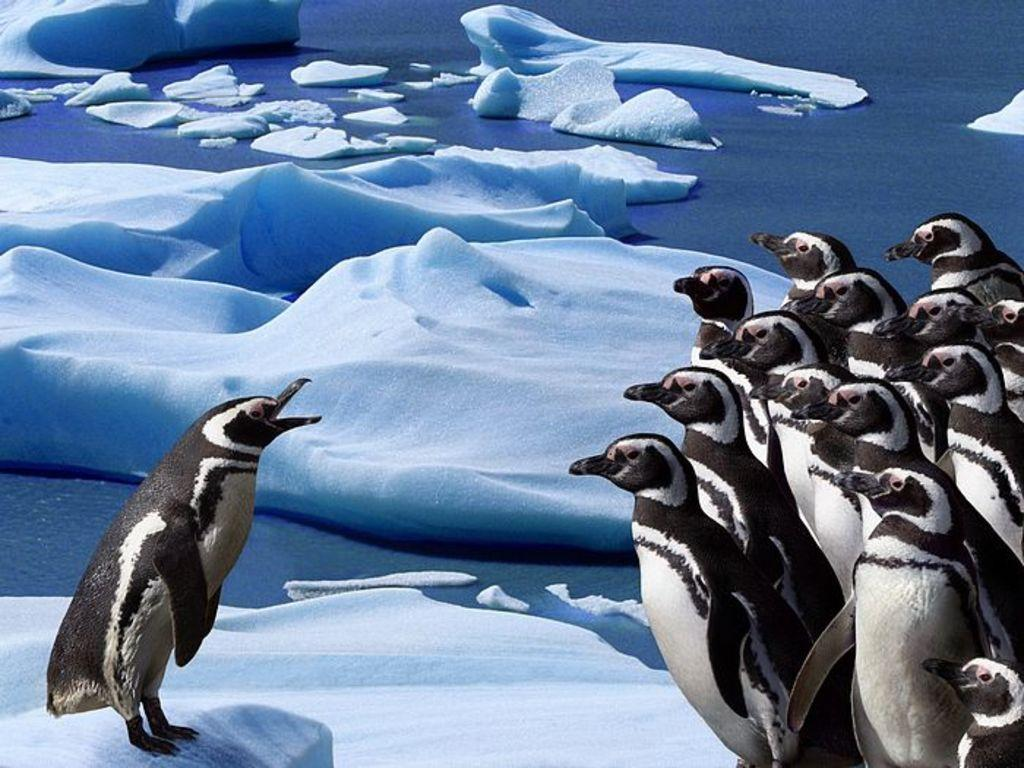What type of animals can be seen on the right side of the image? There are penguins on the right side of the image. What is the environment like in the background of the image? There is snow and water visible in the background of the image. What type of structure can be seen in the image? There is no structure present in the image; it features penguins in a snowy and watery environment. How many screws are visible in the image? There are no screws visible in the image. 